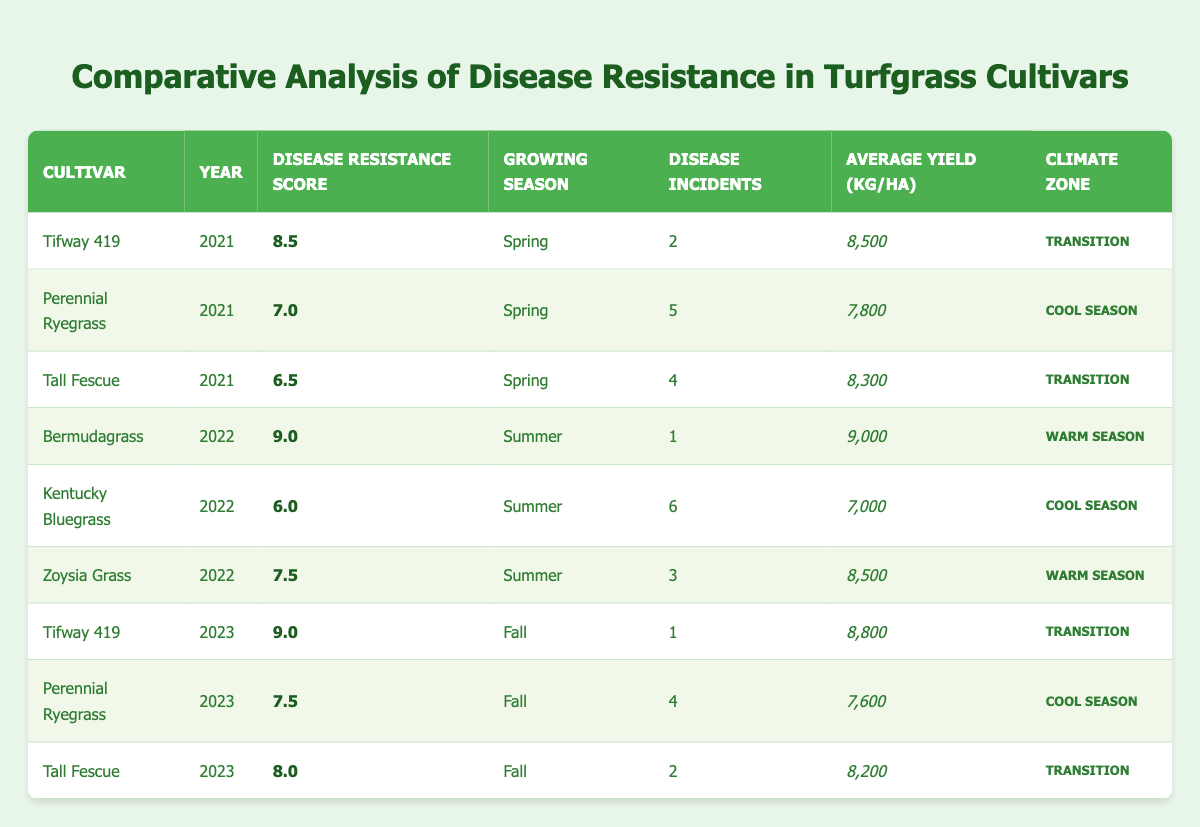What is the highest disease resistance score recorded in the table? The highest disease resistance score can be found by scanning through the disease resistance score column. The maximum score listed is 9.0, attributed to the cultivar Bermudagrass in 2022 and to Tifway 419 in 2023.
Answer: 9.0 Which cultivar had the least number of disease incidents recorded in the data? To find the cultivar with the least disease incidents, we need to look at the disease incidents column and identify the minimum value. The minimum number of incidents found in the data is 1, observed for Bermudagrass in 2022 and both instances of Tifway 419 in 2021 and 2023.
Answer: Bermudagrass What is the average disease resistance score for Tall Fescue across all years? The disease resistance scores for Tall Fescue across the years listed are 6.5 (2021), 8.0 (2023), and there is no record for 2022 because it’s absent. To find the average, we calculate (6.5 + 8.0) / 2 = 7.25.
Answer: 7.25 Is it true that Perennial Ryegrass had a disease resistance score higher than 7 in 2023? By examining the data, Perennial Ryegrass has a disease resistance score of 7.5 in 2023. Since this is indeed higher than 7, the statement is true.
Answer: Yes Which growing season had the most disease incidents overall? We need to sum up the disease incidents for each growing season across all cultivars. The totals are: Spring (2+5+4=11), Summer (1+6+3=10), and Fall (1+4+2=7). Spring has the highest total, which is 11 incidents.
Answer: Spring What is the difference in average yield between Tifway 419 in 2021 and 2023? The average yield for Tifway 419 in 2021 is 8500 kg/ha, and for 2023 it is 8800 kg/ha. To find the difference, we calculate 8800 - 8500 = 300 kg/ha.
Answer: 300 kg/ha Which climate zone had the highest average disease resistance score across all cultivars? To identify the climate zone with the highest average disease resistance score, we categorize the scores by their respective zones. Transition (8.5, 9.0, 8.0), Warm Season (9.0, 7.5), Cool Season (7.0, 6.0, 7.5). The averages are: Transition = (8.5 + 9.0 + 8.0) / 3 = 8.5, Warm Season = (9.0 + 7.5) / 2 = 8.25, Cool Season = (7.0 + 6.0 + 7.5) / 3 = 6.83. The highest average is for Transition at 8.5.
Answer: Transition Did any cultivar perform better in disease resistance from one year to the next based on the data? We need to check the disease resistance scores year-over-year for all cultivars. Tifway 419 improved from 8.5 (2021) to 9.0 (2023), and Bermudagrass improved from not being compared in 2021 (absent) to 9.0 in 2022. Thus, Tifway 419 increased in score, confirming that improvement did occur.
Answer: Yes 